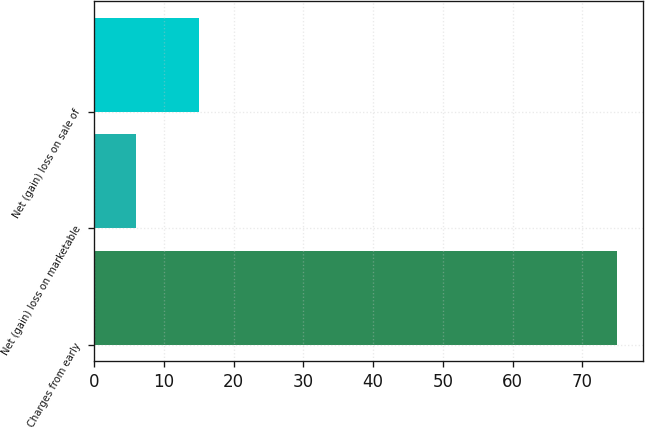Convert chart to OTSL. <chart><loc_0><loc_0><loc_500><loc_500><bar_chart><fcel>Charges from early<fcel>Net (gain) loss on marketable<fcel>Net (gain) loss on sale of<nl><fcel>75<fcel>6<fcel>15<nl></chart> 